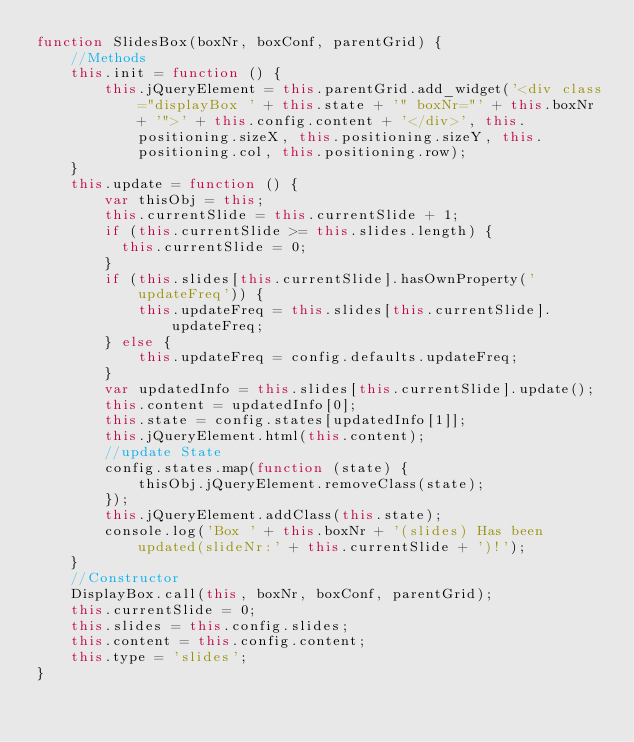<code> <loc_0><loc_0><loc_500><loc_500><_JavaScript_>function SlidesBox(boxNr, boxConf, parentGrid) {
    //Methods
    this.init = function () {
        this.jQueryElement = this.parentGrid.add_widget('<div class="displayBox ' + this.state + '" boxNr="' + this.boxNr + '">' + this.config.content + '</div>', this.positioning.sizeX, this.positioning.sizeY, this.positioning.col, this.positioning.row);
    }
    this.update = function () {
        var thisObj = this;
        this.currentSlide = this.currentSlide + 1;
        if (this.currentSlide >= this.slides.length) {
          this.currentSlide = 0;
        }
        if (this.slides[this.currentSlide].hasOwnProperty('updateFreq')) {
            this.updateFreq = this.slides[this.currentSlide].updateFreq;
        } else {
            this.updateFreq = config.defaults.updateFreq;
        }
        var updatedInfo = this.slides[this.currentSlide].update();
        this.content = updatedInfo[0];
        this.state = config.states[updatedInfo[1]];
        this.jQueryElement.html(this.content);
        //update State
        config.states.map(function (state) {
            thisObj.jQueryElement.removeClass(state);
        });
        this.jQueryElement.addClass(this.state);
        console.log('Box ' + this.boxNr + '(slides) Has been updated(slideNr:' + this.currentSlide + ')!');
    }
    //Constructor
    DisplayBox.call(this, boxNr, boxConf, parentGrid);
    this.currentSlide = 0;
    this.slides = this.config.slides;
    this.content = this.config.content;
    this.type = 'slides';
}</code> 